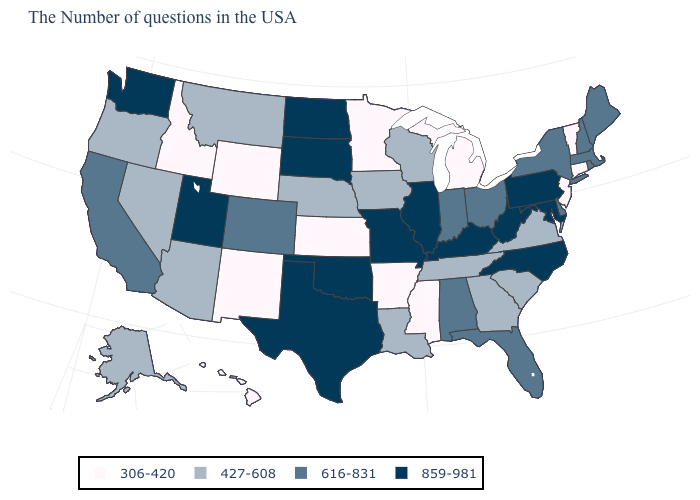Name the states that have a value in the range 859-981?
Write a very short answer. Maryland, Pennsylvania, North Carolina, West Virginia, Kentucky, Illinois, Missouri, Oklahoma, Texas, South Dakota, North Dakota, Utah, Washington. How many symbols are there in the legend?
Quick response, please. 4. What is the value of Connecticut?
Short answer required. 306-420. What is the value of Tennessee?
Quick response, please. 427-608. What is the highest value in the MidWest ?
Short answer required. 859-981. Among the states that border Georgia , does North Carolina have the highest value?
Quick response, please. Yes. Among the states that border Indiana , does Illinois have the highest value?
Concise answer only. Yes. Does the map have missing data?
Write a very short answer. No. What is the value of Kansas?
Keep it brief. 306-420. What is the lowest value in the USA?
Quick response, please. 306-420. Does Delaware have the lowest value in the South?
Keep it brief. No. What is the highest value in the USA?
Be succinct. 859-981. Does Maine have the highest value in the Northeast?
Write a very short answer. No. Does Alaska have a lower value than Tennessee?
Write a very short answer. No. Name the states that have a value in the range 859-981?
Write a very short answer. Maryland, Pennsylvania, North Carolina, West Virginia, Kentucky, Illinois, Missouri, Oklahoma, Texas, South Dakota, North Dakota, Utah, Washington. 